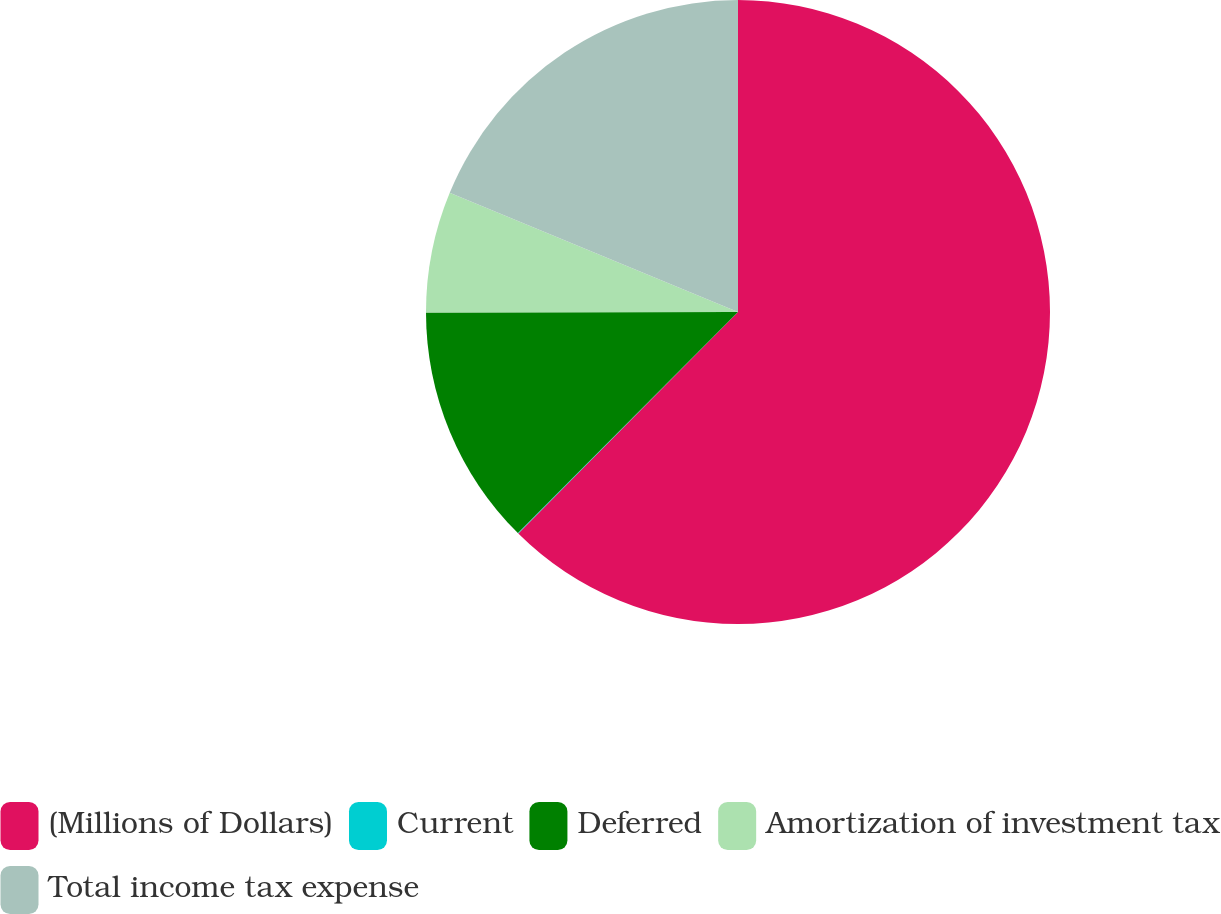<chart> <loc_0><loc_0><loc_500><loc_500><pie_chart><fcel>(Millions of Dollars)<fcel>Current<fcel>Deferred<fcel>Amortization of investment tax<fcel>Total income tax expense<nl><fcel>62.43%<fcel>0.03%<fcel>12.51%<fcel>6.27%<fcel>18.75%<nl></chart> 